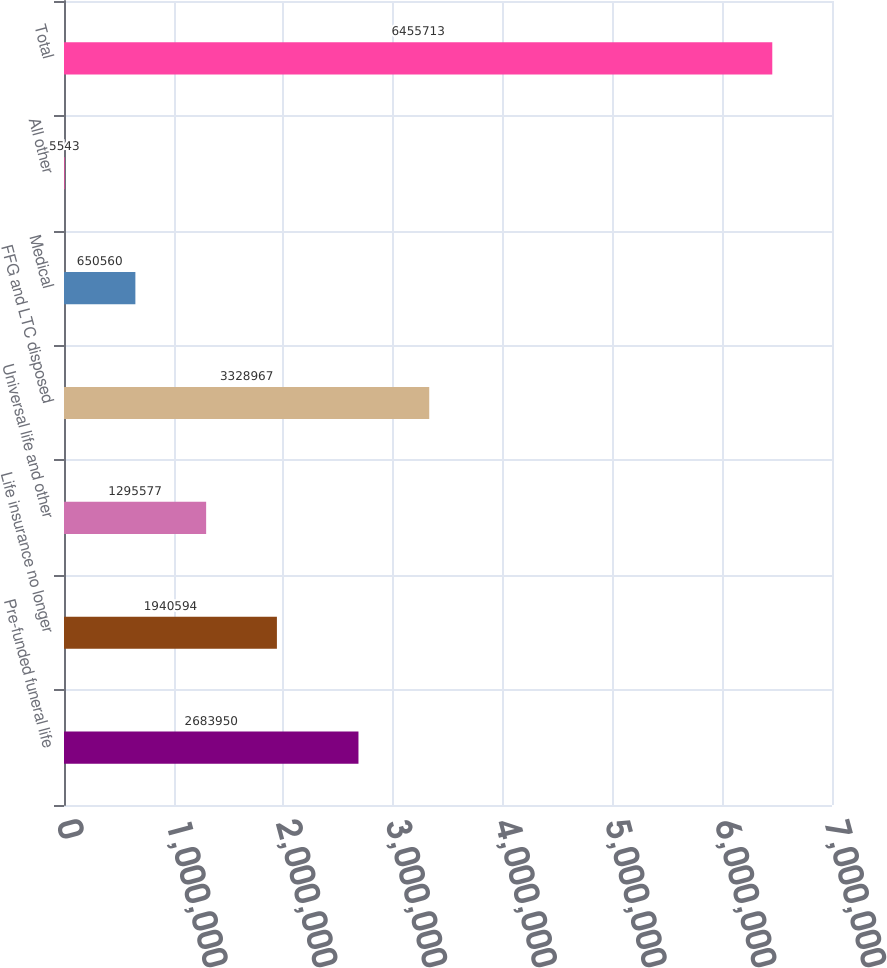Convert chart to OTSL. <chart><loc_0><loc_0><loc_500><loc_500><bar_chart><fcel>Pre-funded funeral life<fcel>Life insurance no longer<fcel>Universal life and other<fcel>FFG and LTC disposed<fcel>Medical<fcel>All other<fcel>Total<nl><fcel>2.68395e+06<fcel>1.94059e+06<fcel>1.29558e+06<fcel>3.32897e+06<fcel>650560<fcel>5543<fcel>6.45571e+06<nl></chart> 